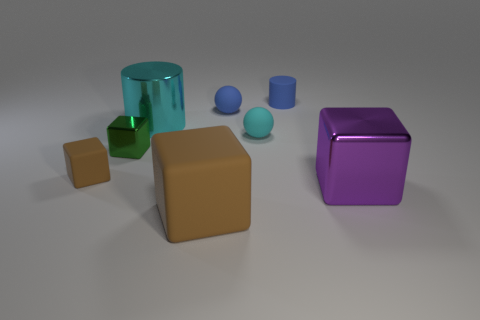What is the shape of the purple object?
Your response must be concise. Cube. Do the tiny blue cylinder and the green block have the same material?
Provide a succinct answer. No. Is the number of tiny cyan rubber balls on the left side of the small green cube the same as the number of blue cylinders in front of the small blue ball?
Your response must be concise. Yes. There is a shiny cube left of the shiny cube to the right of the large brown rubber object; is there a rubber object that is to the left of it?
Your response must be concise. Yes. Is the green shiny object the same size as the cyan cylinder?
Your response must be concise. No. There is a matte ball behind the large shiny object that is behind the small rubber object that is left of the large matte object; what color is it?
Give a very brief answer. Blue. How many big metallic objects have the same color as the big matte block?
Your response must be concise. 0. How many big things are either purple metallic blocks or shiny cylinders?
Make the answer very short. 2. Is there another green thing that has the same shape as the green shiny object?
Your answer should be compact. No. Is the shape of the tiny green thing the same as the purple thing?
Offer a very short reply. Yes. 